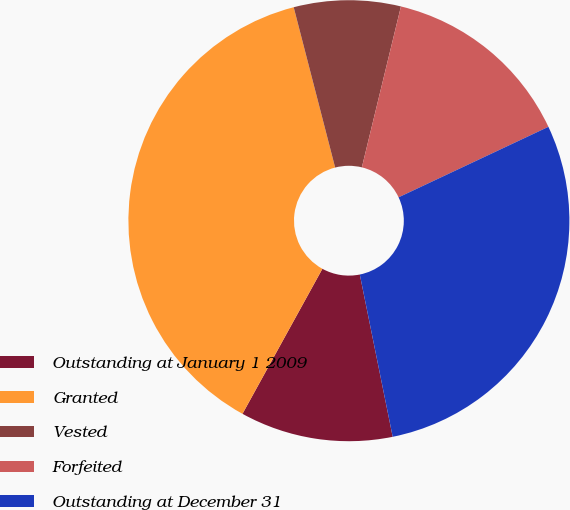Convert chart. <chart><loc_0><loc_0><loc_500><loc_500><pie_chart><fcel>Outstanding at January 1 2009<fcel>Granted<fcel>Vested<fcel>Forfeited<fcel>Outstanding at December 31<nl><fcel>11.2%<fcel>37.96%<fcel>7.82%<fcel>14.21%<fcel>28.82%<nl></chart> 